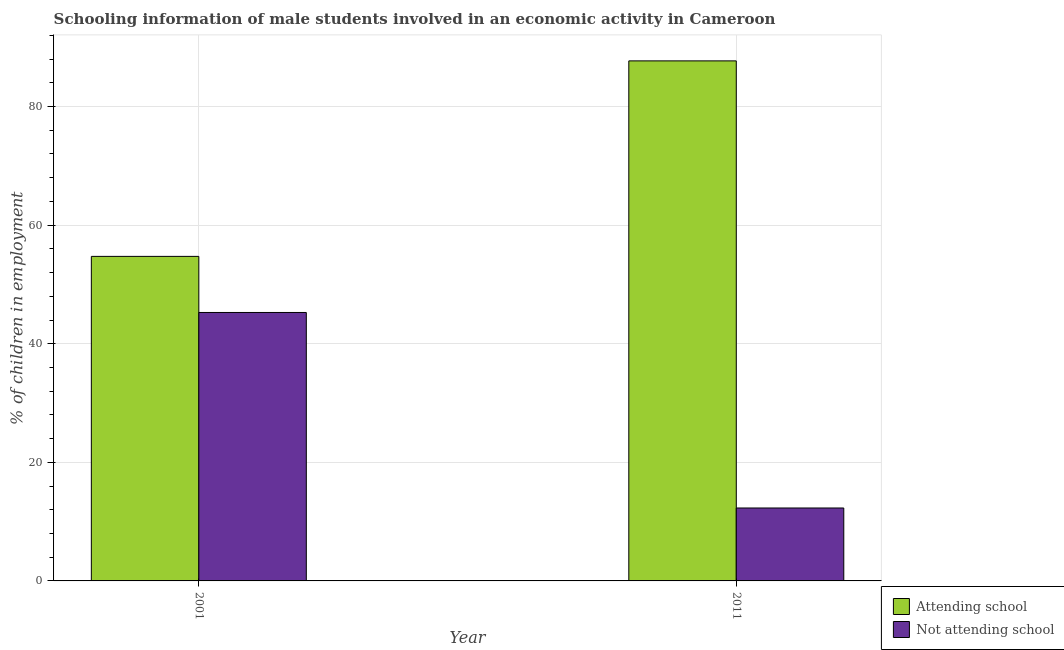How many different coloured bars are there?
Your answer should be compact. 2. How many bars are there on the 2nd tick from the left?
Provide a succinct answer. 2. In how many cases, is the number of bars for a given year not equal to the number of legend labels?
Make the answer very short. 0. What is the percentage of employed males who are attending school in 2001?
Give a very brief answer. 54.73. Across all years, what is the maximum percentage of employed males who are not attending school?
Your answer should be very brief. 45.27. In which year was the percentage of employed males who are not attending school maximum?
Offer a terse response. 2001. What is the total percentage of employed males who are attending school in the graph?
Provide a short and direct response. 142.43. What is the difference between the percentage of employed males who are not attending school in 2001 and that in 2011?
Provide a succinct answer. 32.97. What is the difference between the percentage of employed males who are not attending school in 2011 and the percentage of employed males who are attending school in 2001?
Your answer should be very brief. -32.97. What is the average percentage of employed males who are not attending school per year?
Your answer should be very brief. 28.79. In how many years, is the percentage of employed males who are not attending school greater than 12 %?
Your response must be concise. 2. What is the ratio of the percentage of employed males who are attending school in 2001 to that in 2011?
Provide a short and direct response. 0.62. Is the percentage of employed males who are attending school in 2001 less than that in 2011?
Your response must be concise. Yes. In how many years, is the percentage of employed males who are not attending school greater than the average percentage of employed males who are not attending school taken over all years?
Give a very brief answer. 1. What does the 2nd bar from the left in 2001 represents?
Provide a succinct answer. Not attending school. What does the 2nd bar from the right in 2001 represents?
Your answer should be very brief. Attending school. How many bars are there?
Provide a short and direct response. 4. Are all the bars in the graph horizontal?
Offer a terse response. No. How many years are there in the graph?
Your answer should be very brief. 2. Are the values on the major ticks of Y-axis written in scientific E-notation?
Give a very brief answer. No. Does the graph contain grids?
Make the answer very short. Yes. How many legend labels are there?
Provide a succinct answer. 2. What is the title of the graph?
Your answer should be very brief. Schooling information of male students involved in an economic activity in Cameroon. What is the label or title of the X-axis?
Offer a very short reply. Year. What is the label or title of the Y-axis?
Offer a very short reply. % of children in employment. What is the % of children in employment of Attending school in 2001?
Your answer should be very brief. 54.73. What is the % of children in employment in Not attending school in 2001?
Your answer should be compact. 45.27. What is the % of children in employment in Attending school in 2011?
Your answer should be compact. 87.7. What is the % of children in employment in Not attending school in 2011?
Your answer should be very brief. 12.3. Across all years, what is the maximum % of children in employment of Attending school?
Your answer should be compact. 87.7. Across all years, what is the maximum % of children in employment of Not attending school?
Your answer should be very brief. 45.27. Across all years, what is the minimum % of children in employment of Attending school?
Your answer should be compact. 54.73. Across all years, what is the minimum % of children in employment in Not attending school?
Your answer should be compact. 12.3. What is the total % of children in employment of Attending school in the graph?
Provide a short and direct response. 142.43. What is the total % of children in employment of Not attending school in the graph?
Make the answer very short. 57.57. What is the difference between the % of children in employment of Attending school in 2001 and that in 2011?
Ensure brevity in your answer.  -32.97. What is the difference between the % of children in employment in Not attending school in 2001 and that in 2011?
Provide a succinct answer. 32.97. What is the difference between the % of children in employment of Attending school in 2001 and the % of children in employment of Not attending school in 2011?
Provide a short and direct response. 42.43. What is the average % of children in employment in Attending school per year?
Provide a succinct answer. 71.21. What is the average % of children in employment of Not attending school per year?
Make the answer very short. 28.79. In the year 2001, what is the difference between the % of children in employment of Attending school and % of children in employment of Not attending school?
Your answer should be compact. 9.46. In the year 2011, what is the difference between the % of children in employment of Attending school and % of children in employment of Not attending school?
Give a very brief answer. 75.4. What is the ratio of the % of children in employment of Attending school in 2001 to that in 2011?
Provide a short and direct response. 0.62. What is the ratio of the % of children in employment of Not attending school in 2001 to that in 2011?
Provide a short and direct response. 3.68. What is the difference between the highest and the second highest % of children in employment in Attending school?
Provide a short and direct response. 32.97. What is the difference between the highest and the second highest % of children in employment of Not attending school?
Give a very brief answer. 32.97. What is the difference between the highest and the lowest % of children in employment in Attending school?
Make the answer very short. 32.97. What is the difference between the highest and the lowest % of children in employment in Not attending school?
Provide a succinct answer. 32.97. 